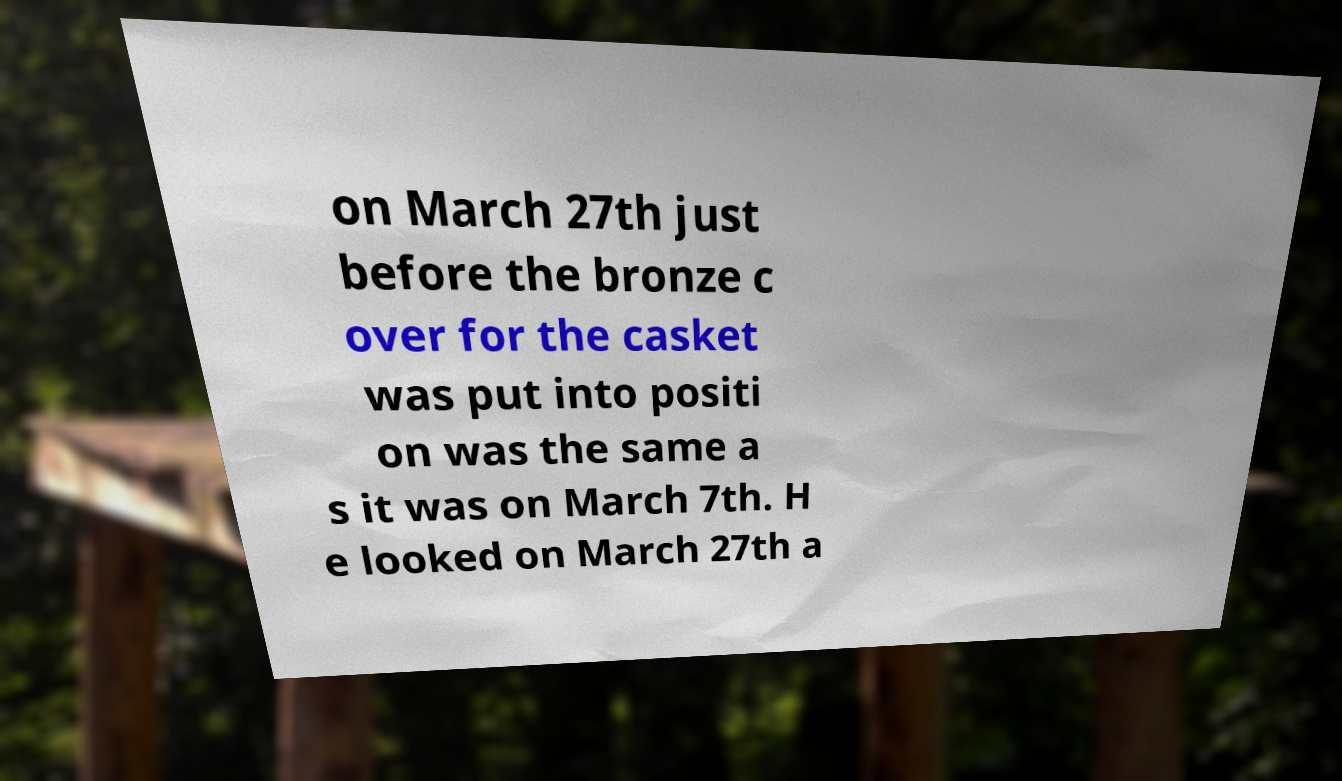Please identify and transcribe the text found in this image. on March 27th just before the bronze c over for the casket was put into positi on was the same a s it was on March 7th. H e looked on March 27th a 